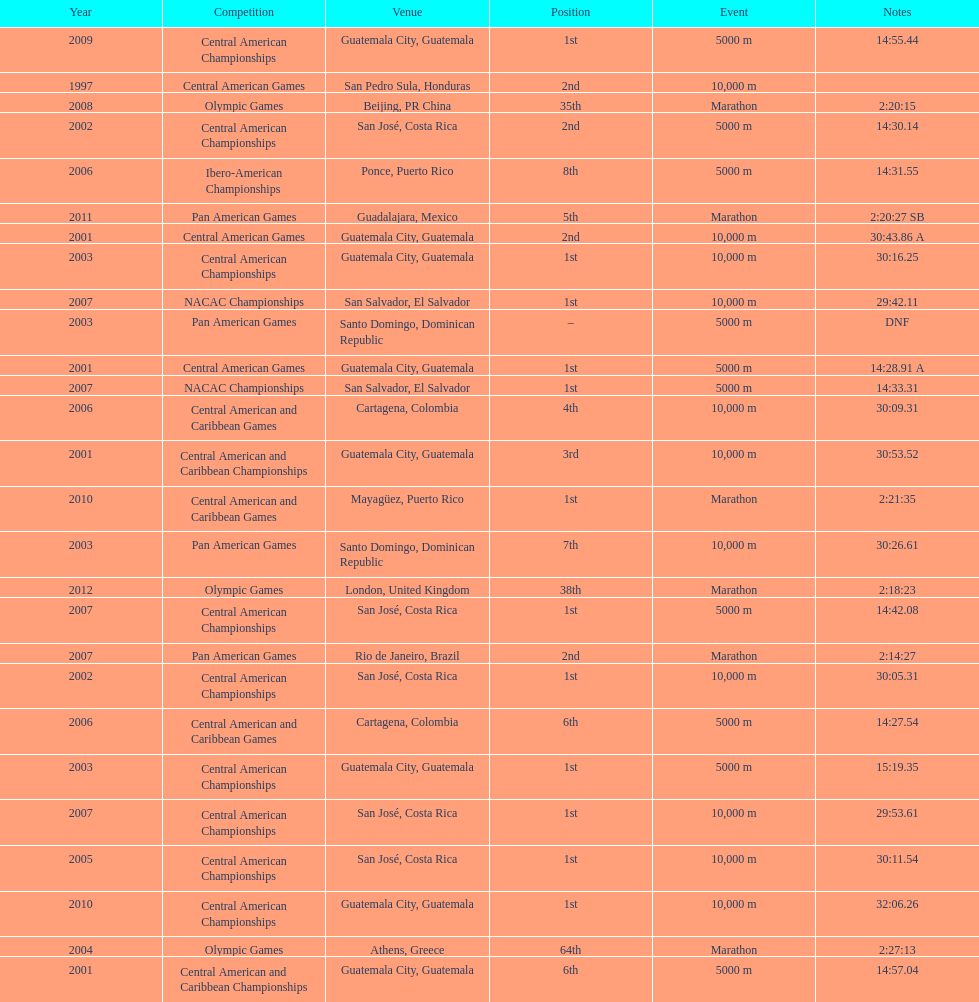Tell me the number of times they competed in guatamala. 5. 